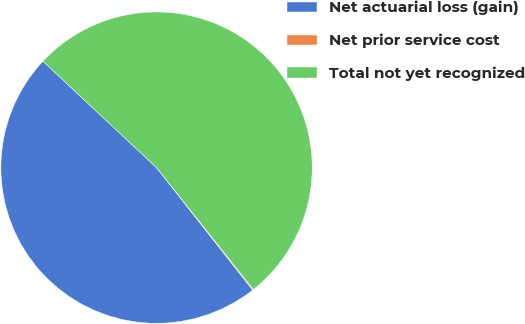<chart> <loc_0><loc_0><loc_500><loc_500><pie_chart><fcel>Net actuarial loss (gain)<fcel>Net prior service cost<fcel>Total not yet recognized<nl><fcel>47.57%<fcel>0.1%<fcel>52.33%<nl></chart> 